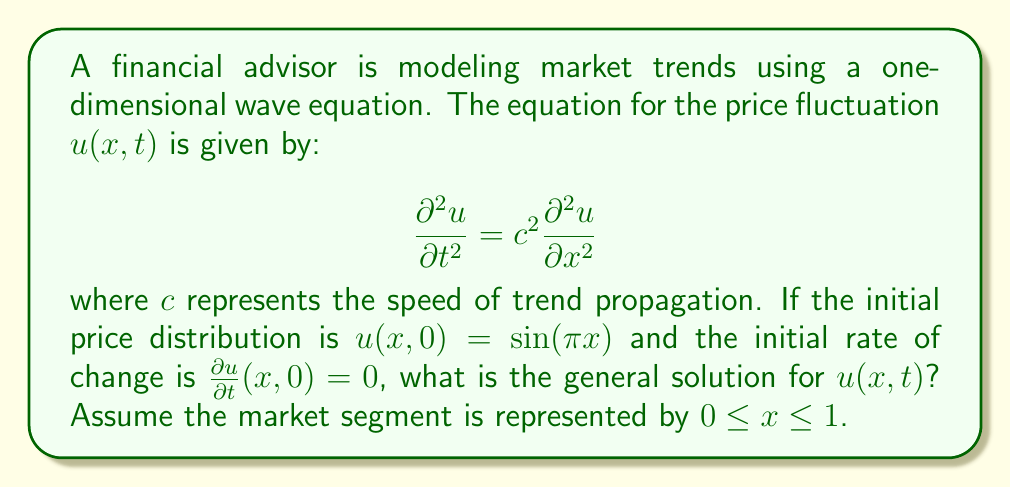Solve this math problem. Let's solve this step-by-step:

1) The general solution for a one-dimensional wave equation with these initial conditions is:

   $$u(x,t) = A\cos(c\pi t)\sin(\pi x) + B\sin(c\pi t)\sin(\pi x)$$

2) We need to determine the constants A and B using the initial conditions.

3) From the first initial condition, $u(x,0) = \sin(\pi x)$:
   
   $$u(x,0) = A\cos(0)\sin(\pi x) + B\sin(0)\sin(\pi x) = A\sin(\pi x)$$

   This implies $A = 1$.

4) From the second initial condition, $\frac{\partial u}{\partial t}(x,0) = 0$:

   $$\frac{\partial u}{\partial t}(x,0) = -Ac\pi\sin(0)\sin(\pi x) + Bc\pi\cos(0)\sin(\pi x) = Bc\pi\sin(\pi x) = 0$$

   This implies $B = 0$.

5) Substituting these values back into the general solution:

   $$u(x,t) = \cos(c\pi t)\sin(\pi x)$$

This solution represents a standing wave, which in financial terms suggests a cyclical market trend that oscillates in place rather than propagating.
Answer: $u(x,t) = \cos(c\pi t)\sin(\pi x)$ 